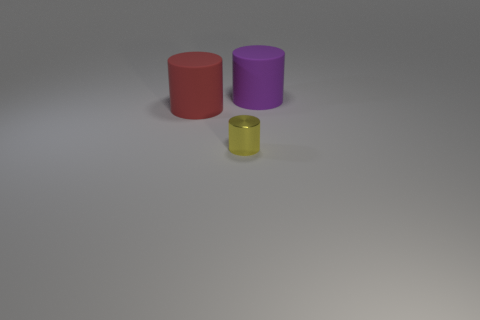Add 2 small metal cylinders. How many objects exist? 5 Subtract all yellow metal things. Subtract all purple matte objects. How many objects are left? 1 Add 1 large red matte cylinders. How many large red matte cylinders are left? 2 Add 2 yellow cylinders. How many yellow cylinders exist? 3 Subtract 0 brown cubes. How many objects are left? 3 